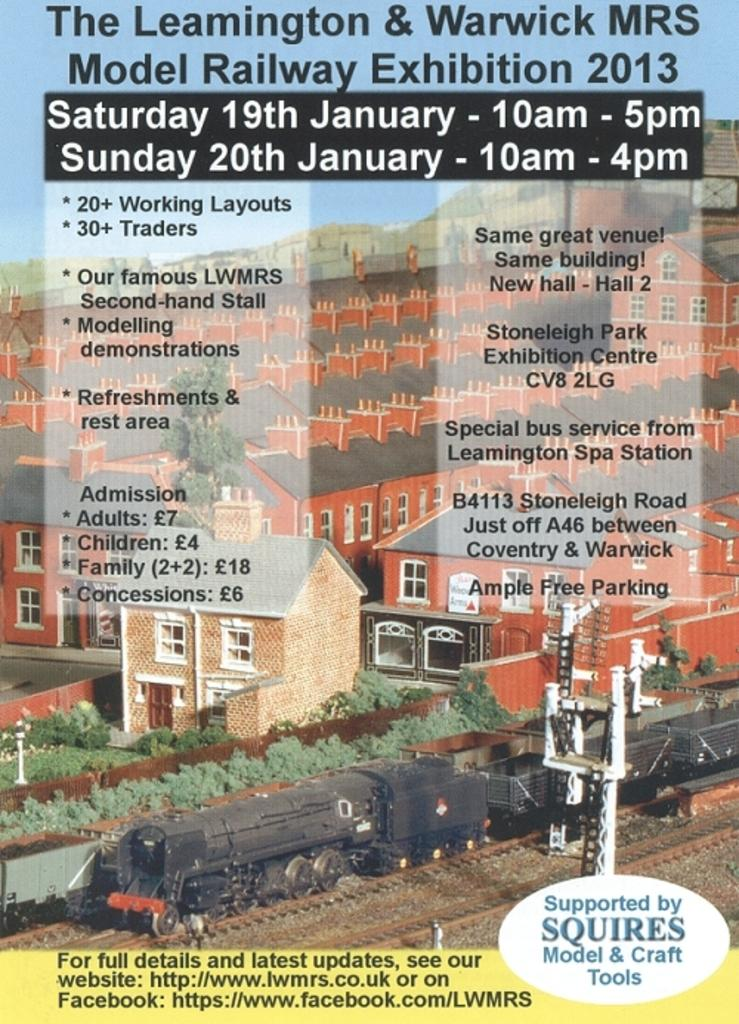<image>
Create a compact narrative representing the image presented. A flyer for a model railway Ehibition that happened in 2013 